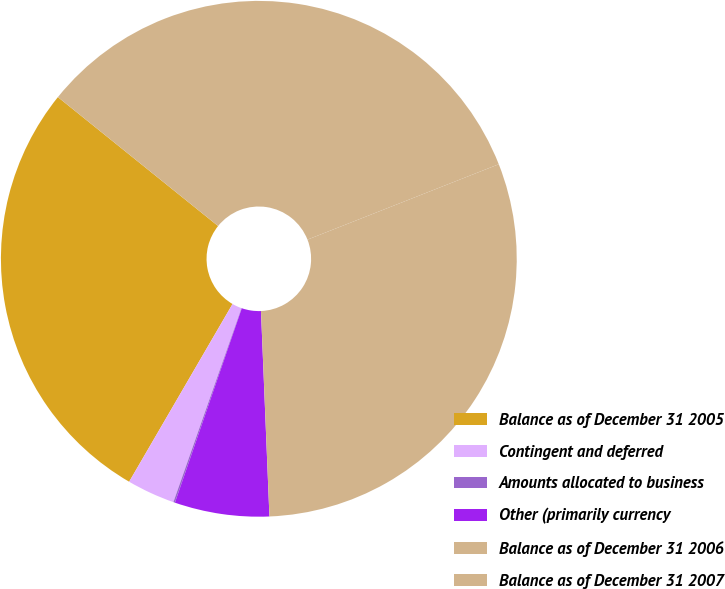Convert chart to OTSL. <chart><loc_0><loc_0><loc_500><loc_500><pie_chart><fcel>Balance as of December 31 2005<fcel>Contingent and deferred<fcel>Amounts allocated to business<fcel>Other (primarily currency<fcel>Balance as of December 31 2006<fcel>Balance as of December 31 2007<nl><fcel>27.4%<fcel>3.01%<fcel>0.1%<fcel>5.93%<fcel>30.32%<fcel>33.24%<nl></chart> 